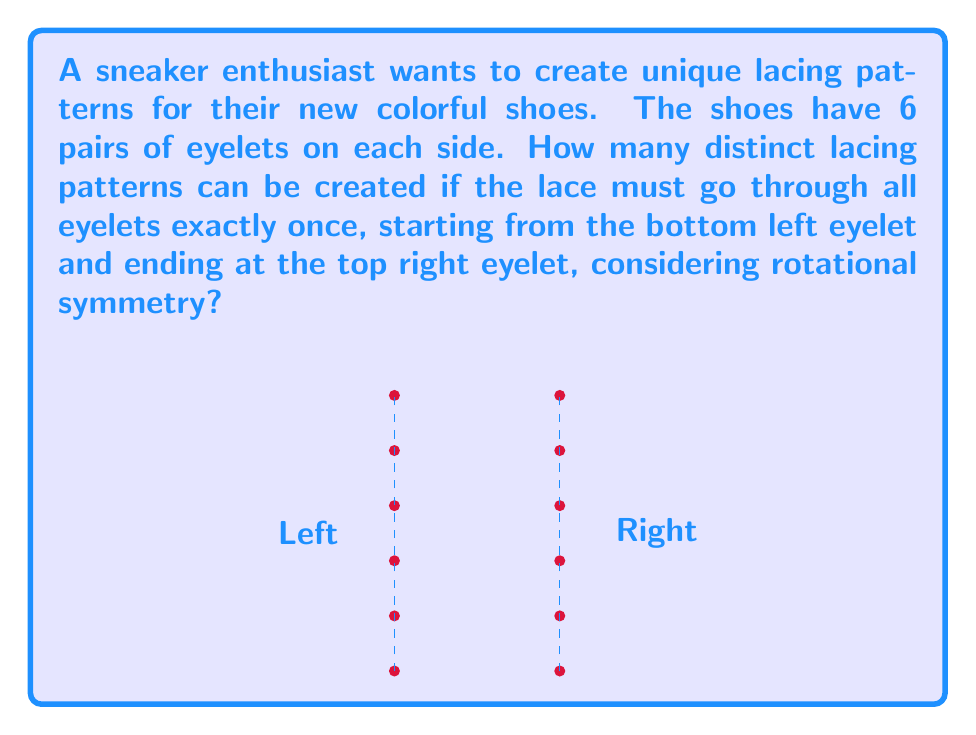Can you answer this question? Let's approach this step-by-step using group theory:

1) First, we need to understand that each lacing pattern can be represented as a permutation of the numbers 1 to 5, where each number represents the right-side eyelet that the lace goes to after passing through the corresponding left-side eyelet.

2) The total number of such permutations is 5! = 120.

3) However, we need to consider rotational symmetry. The dihedral group $D_5$ acts on these permutations, as rotating the shoe by 72° (1/5 of a full rotation) creates an equivalent lacing pattern.

4) The order of $D_5$ is 10 (5 rotations and 5 reflections).

5) By Burnside's lemma, the number of distinct lacing patterns is given by:

   $$\frac{1}{|G|} \sum_{g \in G} |X^g|$$

   where $G$ is the group ($D_5$ in this case), and $X^g$ is the set of elements fixed by $g$.

6) For the identity element, all 120 permutations are fixed.
   For each of the 4 non-identity rotations, only the identity permutation is fixed.
   For each of the 5 reflections, 4 permutations are fixed.

7) Therefore, the sum is:

   $$120 + 4(1) + 5(4) = 140$$

8) Dividing by $|G| = 10$:

   $$\frac{140}{10} = 14$$

Thus, there are 14 distinct lacing patterns considering rotational symmetry.
Answer: 14 